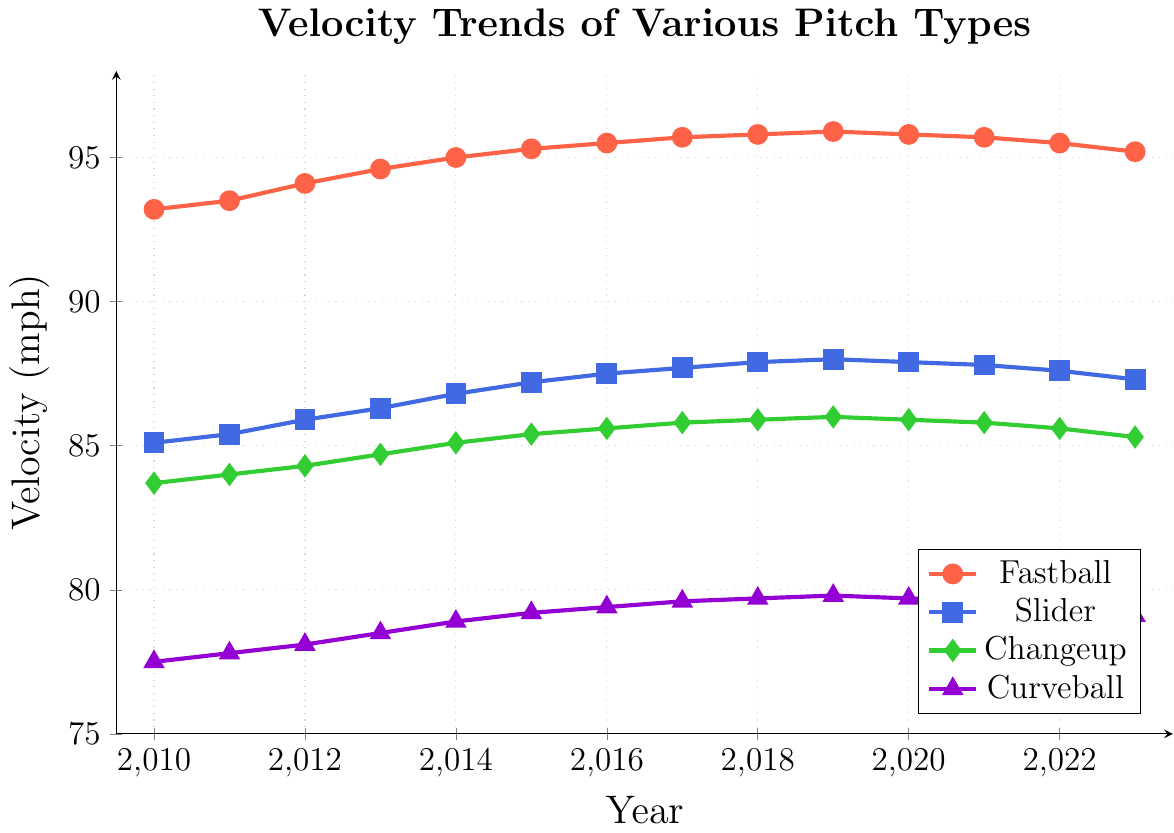How did the fastball velocity change from 2010 to 2015? To determine the change in fastball velocity from 2010 to 2015, we subtract the velocity in 2010 from the velocity in 2015. Fastball velocity in 2010 is 93.2 mph, and in 2015, it is 95.3 mph. The change is 95.3 - 93.2 = 2.1 mph.
Answer: 2.1 mph Which pitch type had the largest increase in velocity over the entire period? To find the pitch with the largest increase in velocity, we calculate the difference between the velocity in 2023 and 2010 for each pitch type. Fastball: 95.2 - 93.2 = 2.0 mph. Slider: 87.3 - 85.1 = 2.2 mph. Changeup: 85.3 - 83.7 = 1.6 mph. Curveball: 79.1 - 77.5 = 1.6 mph. The Slider had the largest increase.
Answer: Slider What is the average velocity of the fastball from 2010 to 2023? To find the average, sum the fastball velocities from 2010 to 2023 and divide by the number of years. Sum: 93.2 + 93.5 + 94.1 + 94.6 + 95.0 + 95.3 + 95.5 + 95.7 + 95.8 + 95.9 + 95.8 + 95.7 + 95.5 + 95.2 = 1300.8. Number of years: 14. Average = 1300.8 / 14 = 92.914.
Answer: 92.914 How did the changeup velocity trend between 2020 and 2023? To identify the trend, we look at the changeup velocities each year from 2020 to 2023. In 2020: 85.9 mph, 2021: 85.8 mph, 2022: 85.6 mph, and 2023: 85.3 mph. The trend shows a steady decrease.
Answer: Decreasing Which pitch type has the smallest velocity range from 2010 to 2023? To find the smallest velocity range, calculate the range (maximum - minimum) for each pitch type. Fastball range: 95.9 - 93.2 = 2.7 mph. Slider range: 88.0 - 85.1 = 2.9 mph. Changeup range: 86.0 - 83.7 = 2.3 mph. Curveball range: 79.8 - 77.5 = 2.3 mph. Both Changeup and Curveball have the smallest range.
Answer: Changeup and Curveball In which year did the curveball velocity first exceed 79 mph? To determine this, look for the first year where curveball velocity is greater than 79 mph. In 2015, the velocity was 79.2 mph. Thus, 2015 is the year.
Answer: 2015 Compare the velocities of the slider and curveball in 2019. Which one was faster and by how much? In 2019, the slider velocity was 88.0 mph, and the curveball velocity was 79.8 mph. To find which is faster and by how much, we subtract the curveball velocity from the slider's. 88.0 - 79.8 = 8.2 mph. The slider was faster by 8.2 mph.
Answer: Slider by 8.2 mph Which pitch type maintained the most consistent velocity from 2010 to 2023? Consistency can be assessed by the smallest rate of change or least variation in velocity. By reviewing the incremental changes, we observe that Fastball varies the least from one year to the next compared to the others, suggesting the highest consistency.
Answer: Fastball 